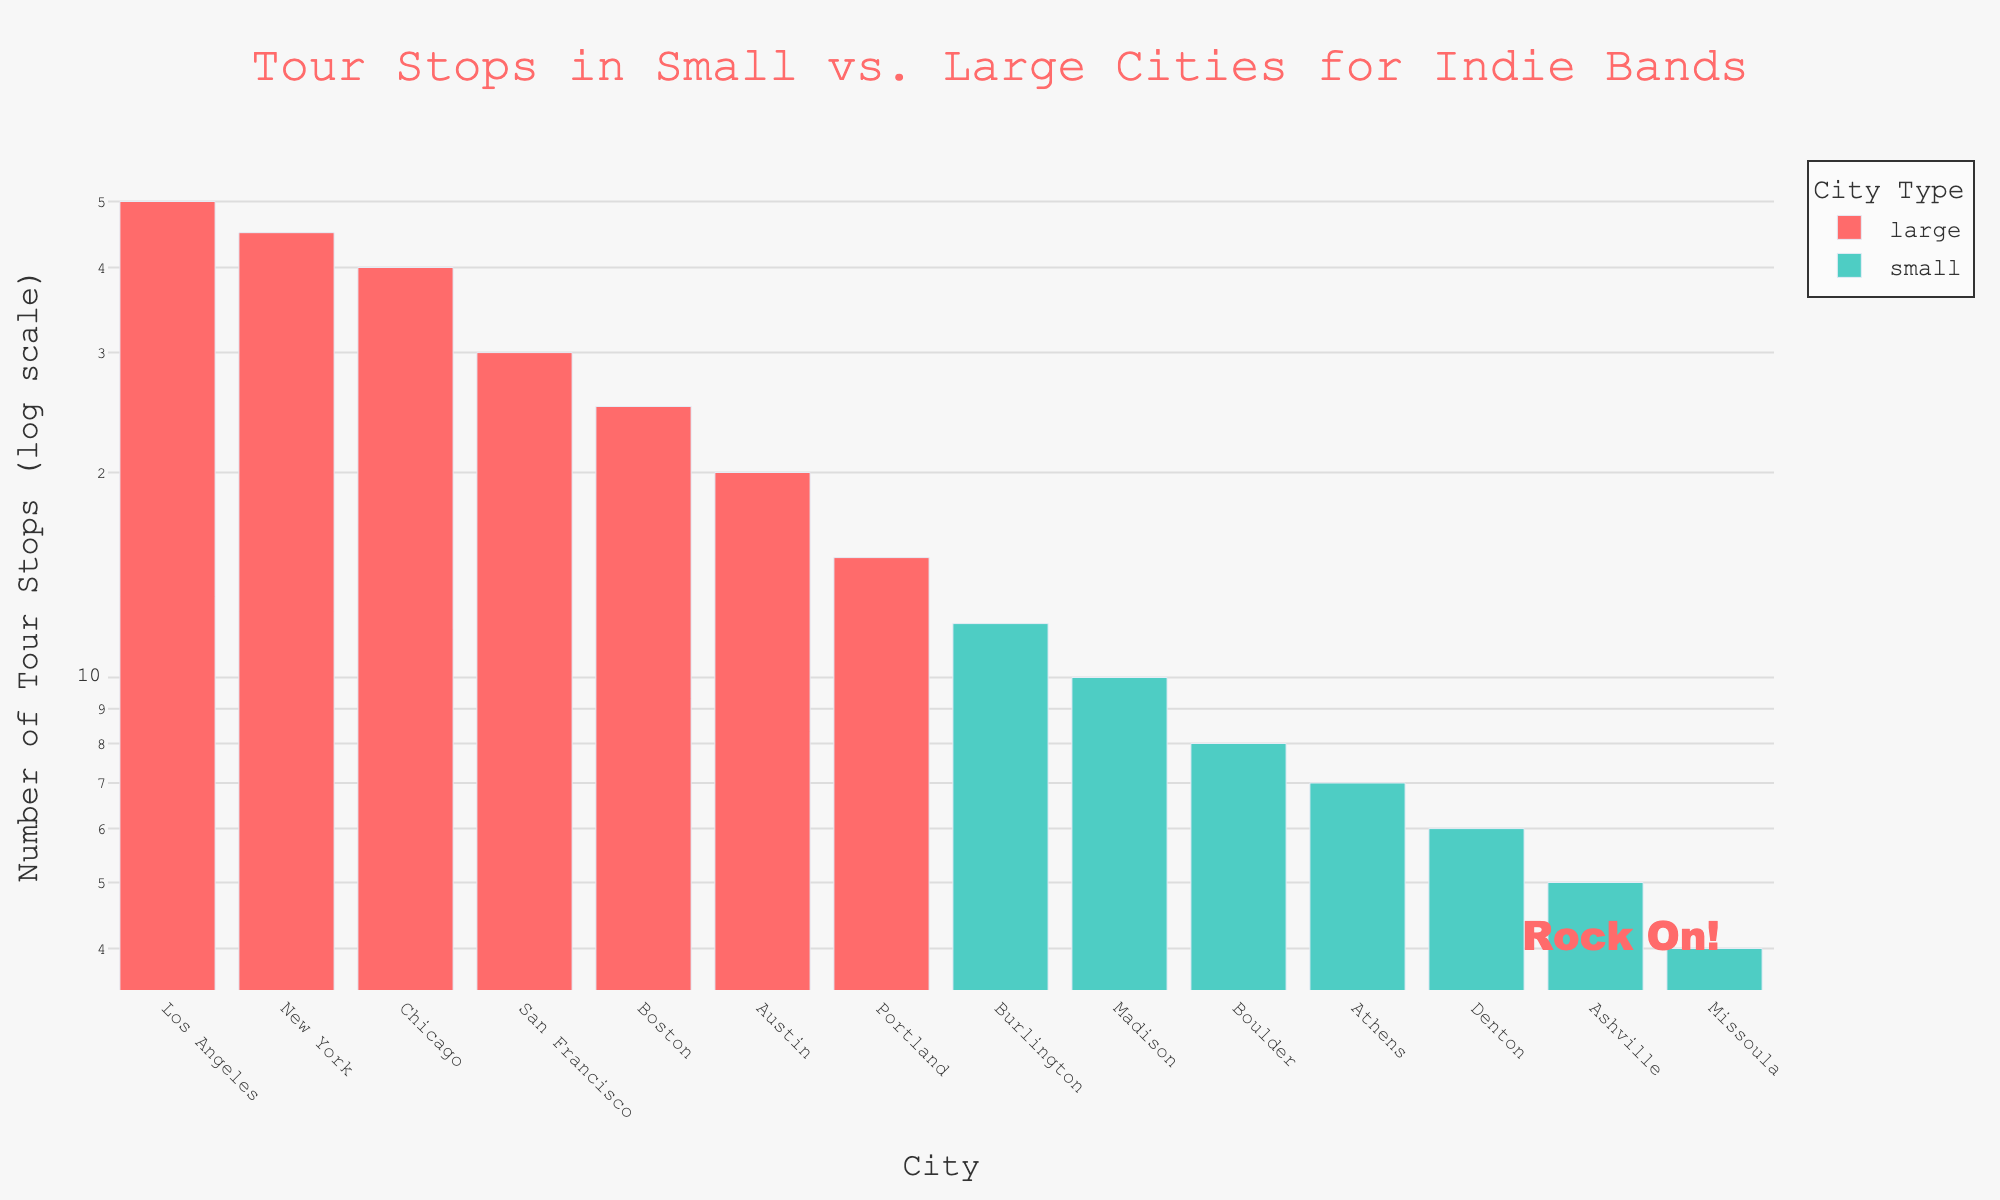what is the title of the figure? The title is at the top of the figure and provides an overview of the plotted data. In this case, it states the main subject and comparison details.
Answer: Tour Stops in Small vs. Large Cities for Indie Bands what is the color used to represent large cities? The color representing large cities can be identified from the legend on the plot, which shows that large cities have a specific color.
Answer: Red which city has the highest number of tour stops? By looking at the tallest bar in the figure, we can identify the city with the highest frequency of tour stops.
Answer: Los Angeles compare the number of tour stops between New York and Boulder Find the bars corresponding to New York and Boulder and compare their heights. Each city's frequency can be read directly above its bar.
Answer: New York: 45, Boulder: 8 how many large cities are shown in the figure? The legend categorizes and colors the cities. Counting all the bars colored for large cities gives us the number of large cities represented.
Answer: 7 what is the median number of tour stops for small cities? List all frequencies for small cities: 10, 8, 12, 5, 7, 6, 4. Sort them and find the middle value.
Answer: 7 which two cities have the closest number of tour stops and what are their frequencies? Compare the heights of bars across all cities and identify the two with the most similar frequencies.
Answer: Burlington and Madison: 12 and 10 how many times higher is the frequency of tour stops in Los Angeles compared to Missoula? Divide the frequency of tour stops in Los Angeles by the frequency in Missoula.
Answer: 50 / 4 = 12.5 which city has the lowest number of tour stops, and what is the frequency? Find the shortest bar in the figure, which indicates the lowest frequency.
Answer: Missoula: 4 what’s the average number of tour stops in large cities? Sum the frequencies for all large cities and divide by the number of large cities.
Answer: (50 + 45 + 40 + 30 + 25 + 20 + 15) / 7 ≈ 32.14 